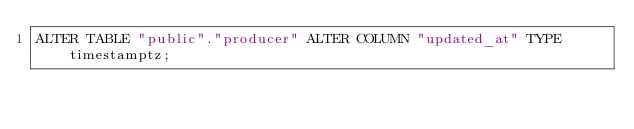<code> <loc_0><loc_0><loc_500><loc_500><_SQL_>ALTER TABLE "public"."producer" ALTER COLUMN "updated_at" TYPE timestamptz;
</code> 